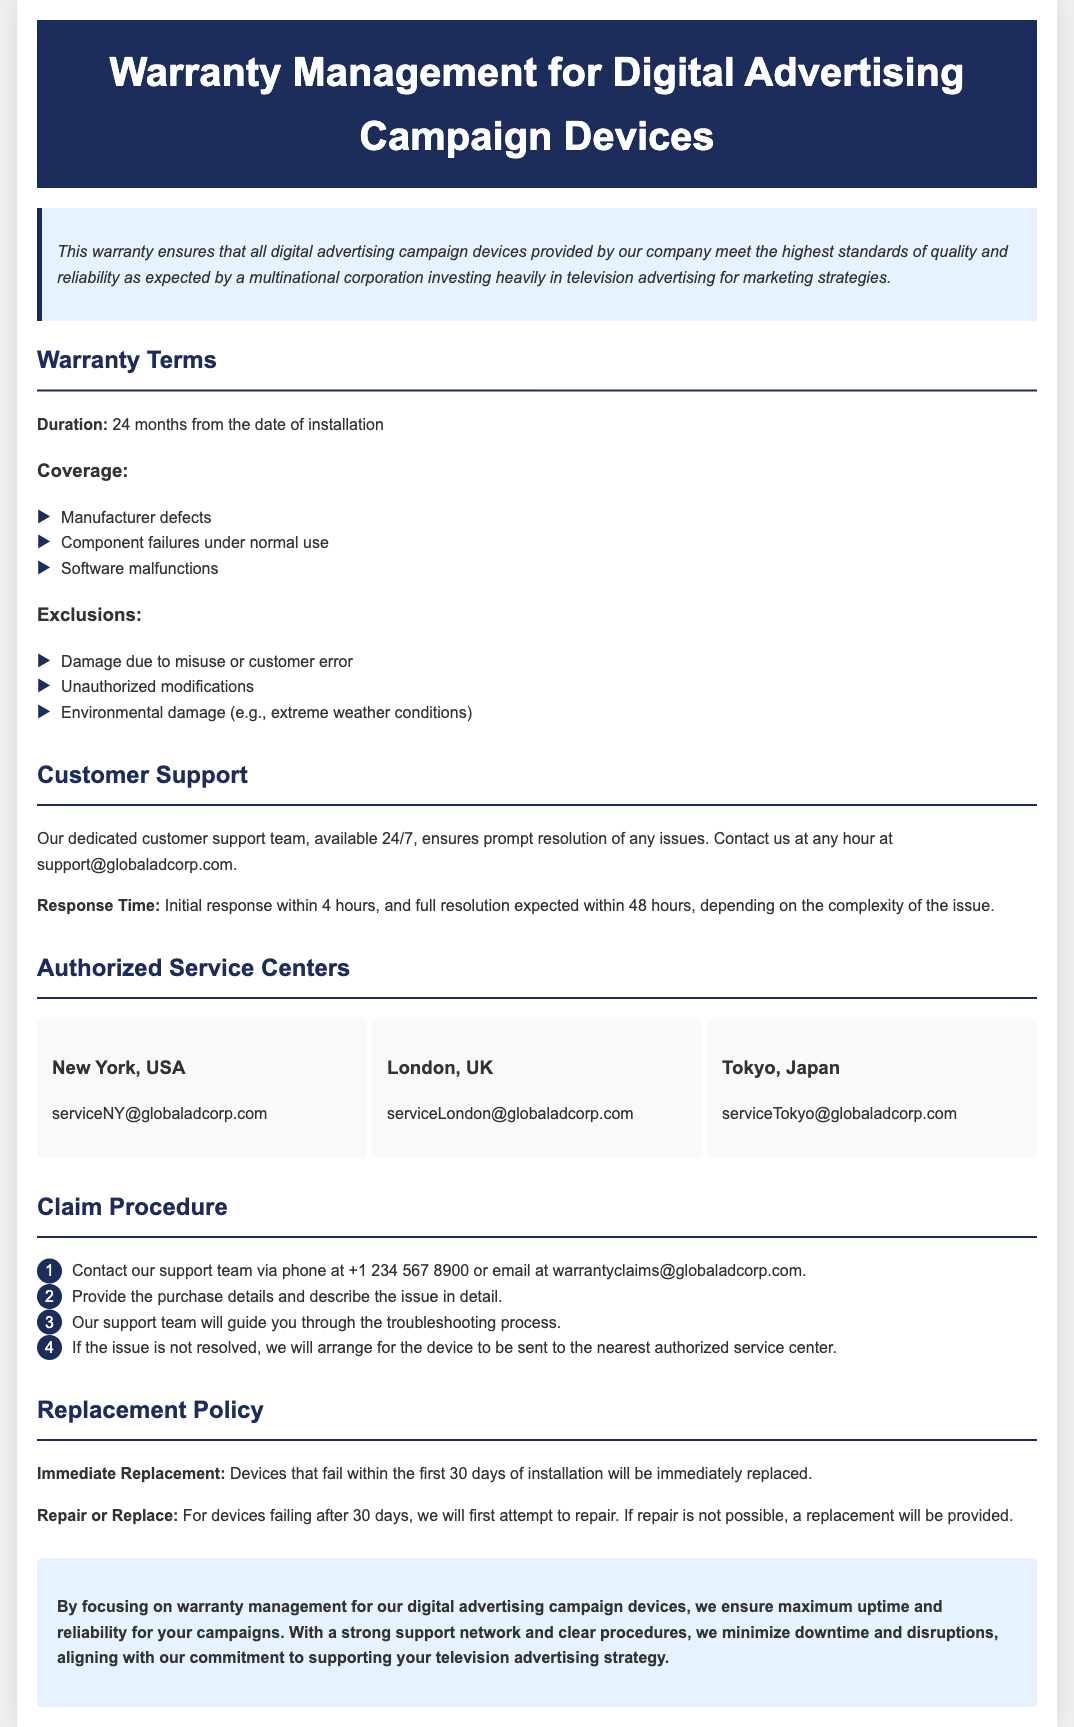What is the duration of the warranty? The duration of the warranty is specified as 24 months from the date of installation.
Answer: 24 months What types of coverage are included? The document lists manufacturer defects, component failures under normal use, and software malfunctions as covered issues.
Answer: Manufacturer defects, component failures, software malfunctions What is the initial response time for customer support? The initial response time for customer support is mentioned as 4 hours.
Answer: 4 hours Where is the authorized service center in Japan located? The document specifies Tokyo, Japan, as the location of the authorized service center.
Answer: Tokyo What is the replacement policy for devices failing within the first 30 days? The document states that devices failing within the first 30 days will be immediately replaced.
Answer: Immediately replaced How will issues be resolved if troubleshooting does not work? If the issue is not resolved, the device will be sent to the nearest authorized service center.
Answer: Send to authorized service center What type of damage is excluded from the warranty? Damage due to misuse or customer error is listed as an exclusion.
Answer: Misuse or customer error What contact method is available for warranty claims? The document provides an email address for warranty claims as warrantyclaims@globaladcorp.com.
Answer: warrantyclaims@globaladcorp.com 